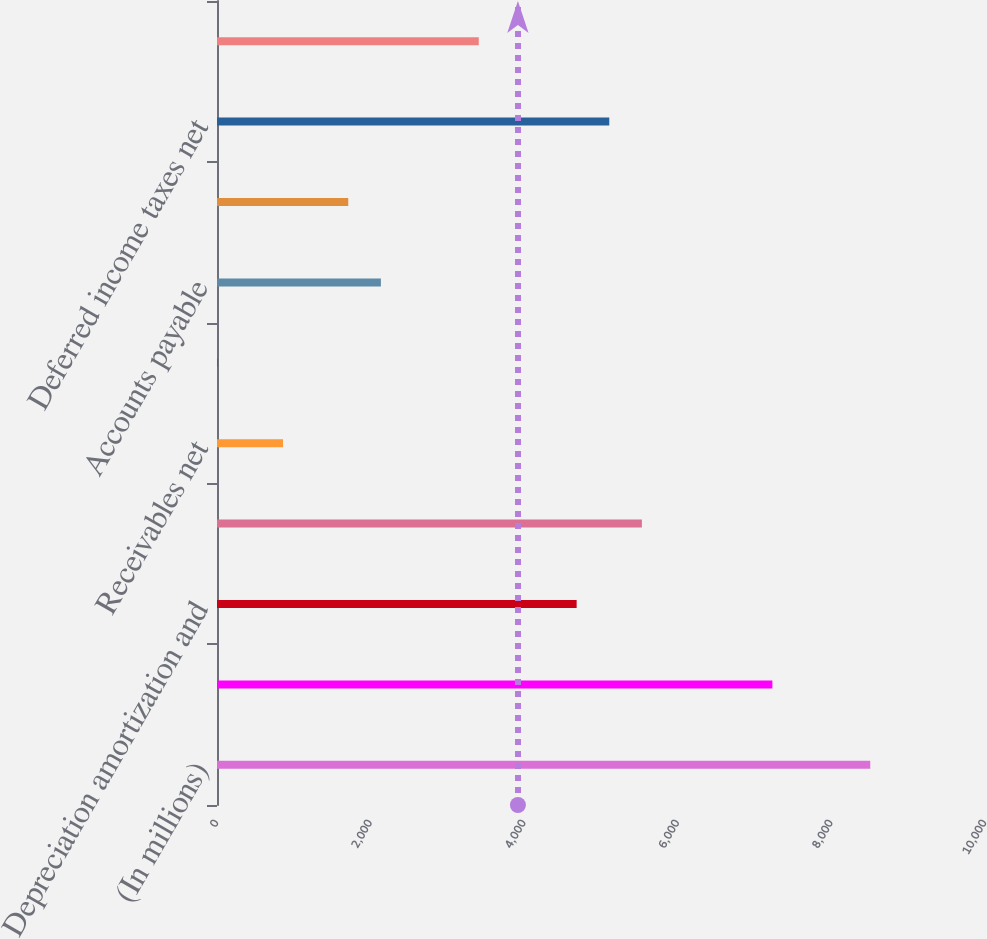Convert chart. <chart><loc_0><loc_0><loc_500><loc_500><bar_chart><fcel>(In millions)<fcel>Net income<fcel>Depreciation amortization and<fcel>Stock-based compensation<fcel>Receivables net<fcel>Other assets<fcel>Accounts payable<fcel>Accrued and other liabilities<fcel>Deferred income taxes net<fcel>Deferred net revenue<nl><fcel>8506<fcel>7231.6<fcel>4682.8<fcel>5532.4<fcel>859.6<fcel>10<fcel>2134<fcel>1709.2<fcel>5107.6<fcel>3408.4<nl></chart> 